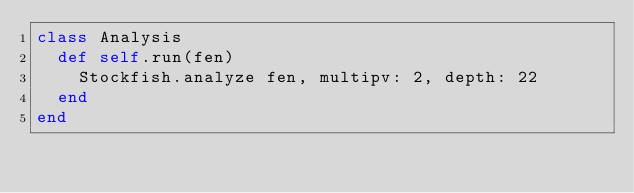<code> <loc_0><loc_0><loc_500><loc_500><_Ruby_>class Analysis
  def self.run(fen)
    Stockfish.analyze fen, multipv: 2, depth: 22
  end
end
</code> 